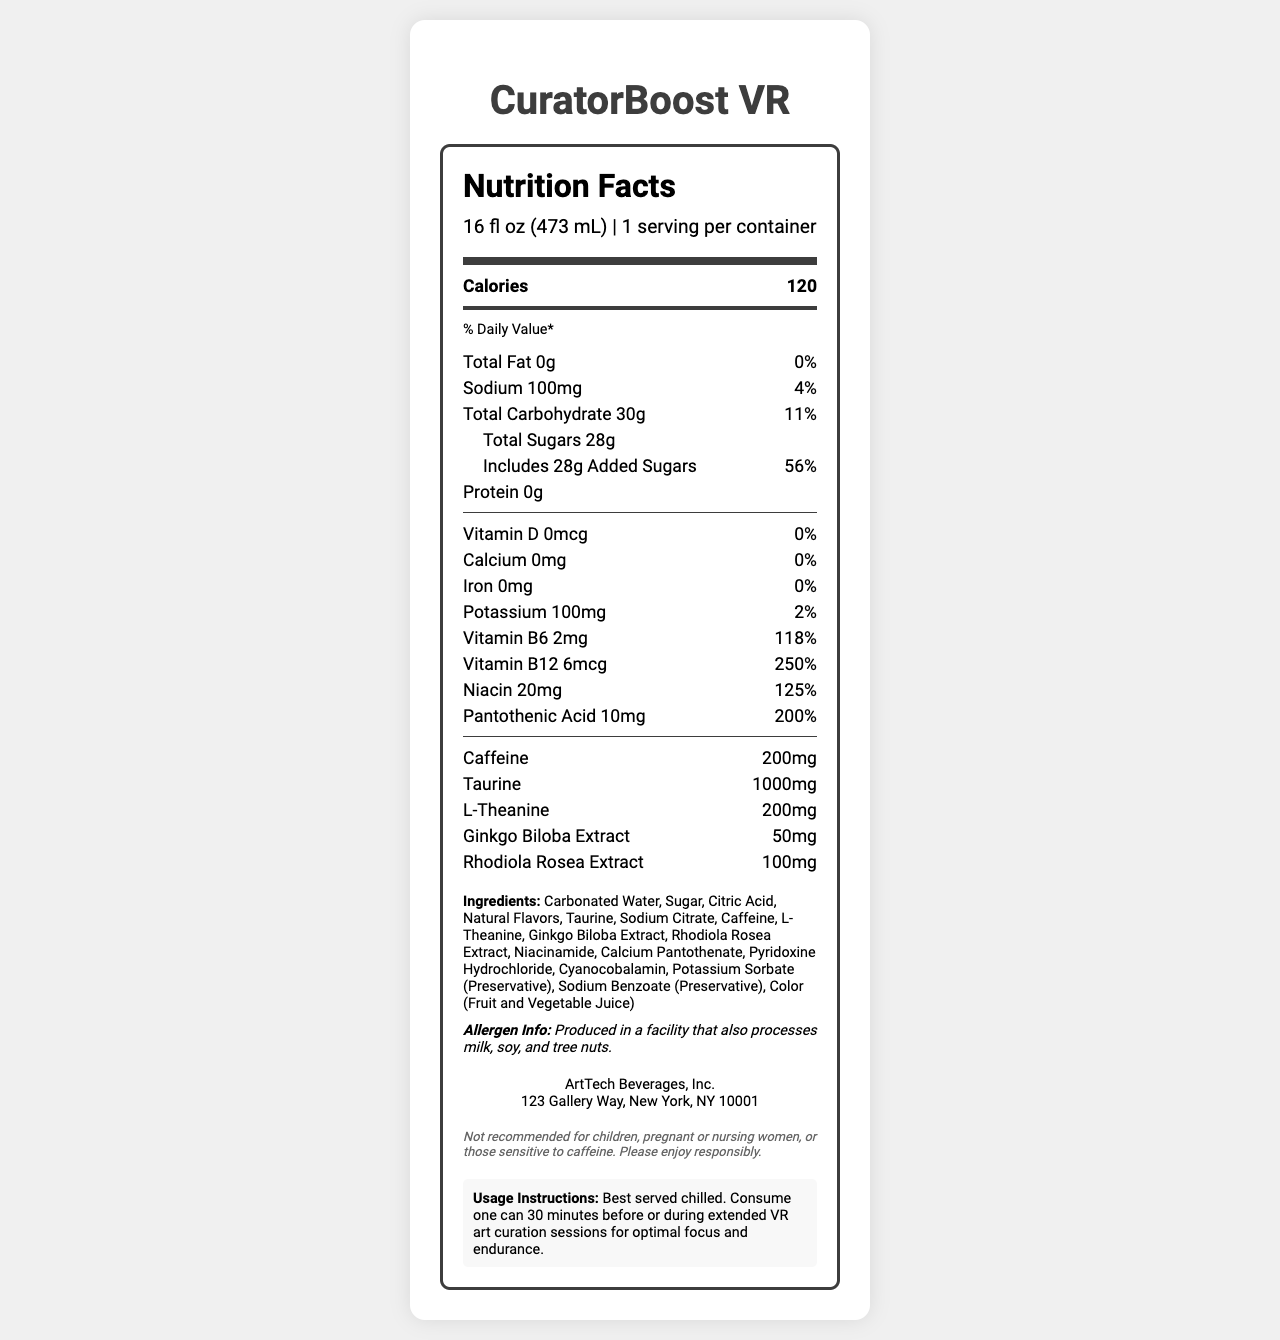what is the serving size of CuratorBoost VR? The serving size is clearly mentioned at the top of the nutrition facts section.
Answer: 16 fl oz (473 mL) how many calories are in one serving? The calorie count is listed near the top of the nutrition facts under "Calories".
Answer: 120 what is the percentage of daily value for Vitamin B12? The daily value percentage for Vitamin B12 is given as 250% in the vitamin section.
Answer: 250% list the main active ingredients in CuratorBoost VR. These are listed under the nutrition items towards the bottom of the main nutrients section.
Answer: Caffeine, Taurine, L-Theanine, Ginkgo Biloba Extract, Rhodiola Rosea Extract what is the total amount of sugars in CuratorBoost VR? The total amount of sugars is listed as 28g under the carbohydrate section.
Answer: 28g which vitamin in CuratorBoost VR has the highest daily value percentage? A. Vitamin D B. Vitamin B6 C. Vitamin B12 D. Niacin Vitamin B12 has a daily value percentage of 250%, which is the highest among the listed vitamins.
Answer: C. Vitamin B12 what is the amount of sodium in CuratorBoost VR? A. 50mg B. 100mg C. 150mg D. 200mg The amount of sodium is listed as 100mg in the sodium section.
Answer: B. 100mg is CuratorBoost VR recommended for pregnant women? The disclaimer at the bottom of the label advises against its use by pregnant women.
Answer: No describe the main purpose and recommendation for using CuratorBoost VR. The usage instructions at the bottom provide a clear summary of the product's purpose and recommended use.
Answer: CuratorBoost VR is an energy drink designed for long hours of virtual reality art curation. It is recommended to be served chilled and consumed one can 30 minutes before or during extended VR art curation sessions for optimal focus and endurance. does CuratorBoost VR contain any protein? The protein content is listed as 0g in the nutrition facts section.
Answer: No how much pantothenic acid is in CuratorBoost VR? The amount of pantothenic acid is listed as 10mg in the vitamins section.
Answer: 10mg what are the potential allergens in CuratorBoost VR? The allergen info mentions that it is produced in a facility that processes milk, soy, and tree nuts, but it does not specify if any are directly in the product.
Answer: Not enough information what is the percentage daily value for sodium? The percentage daily value for sodium is listed as 4%.
Answer: 4% what is the address of the manufacturer of CuratorBoost VR? The manufacturer's address is provided at the bottom in the manufacturer info section.
Answer: 123 Gallery Way, New York, NY 10001 what preservatives are used in CuratorBoost VR? These are listed under the ingredients section as preservatives.
Answer: Potassium Sorbate, Sodium Benzoate 